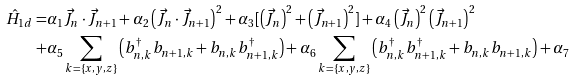<formula> <loc_0><loc_0><loc_500><loc_500>\hat { H } _ { 1 d } = & \alpha _ { 1 } \vec { J } _ { n } \cdot \vec { J } _ { n + 1 } + \alpha _ { 2 } \left ( \vec { J } _ { n } \cdot \vec { J } _ { n + 1 } \right ) ^ { 2 } + \alpha _ { 3 } [ \left ( \vec { J } _ { n } \right ) ^ { 2 } + \left ( \vec { J } _ { n + 1 } \right ) ^ { 2 } ] + \alpha _ { 4 } \left ( \vec { J } _ { n } \right ) ^ { 2 } \left ( \vec { J } _ { n + 1 } \right ) ^ { 2 } \\ + & \alpha _ { 5 } \sum _ { k = \{ x , y , z \} } \left ( b ^ { \dagger } _ { n , k } b _ { n + 1 , k } + b _ { n , k } b ^ { \dagger } _ { n + 1 , k } \right ) + \alpha _ { 6 } \sum _ { k = \{ x , y , z \} } \left ( b ^ { \dagger } _ { n , k } b ^ { \dagger } _ { n + 1 , k } + b _ { n , k } b _ { n + 1 , k } \right ) + \alpha _ { 7 }</formula> 